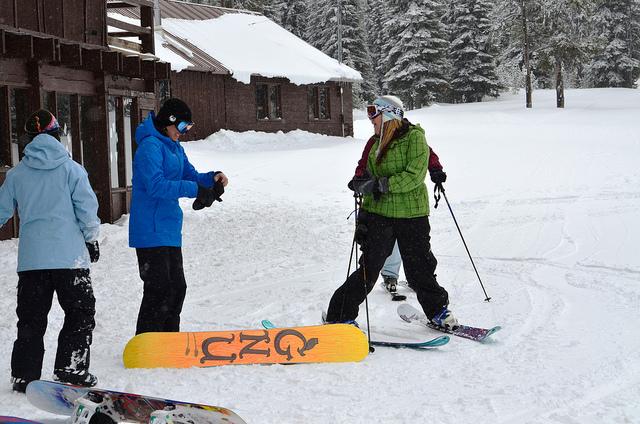How many people are wearing goggles?
Short answer required. 2. Is the snow deep?
Short answer required. Yes. What is written on the bottom of the board?
Concise answer only. Gnu. How many girls are in this group?
Quick response, please. 2. What is written on the snowboard?
Be succinct. Gnu. How many skiers don't have poles?
Give a very brief answer. 2. 